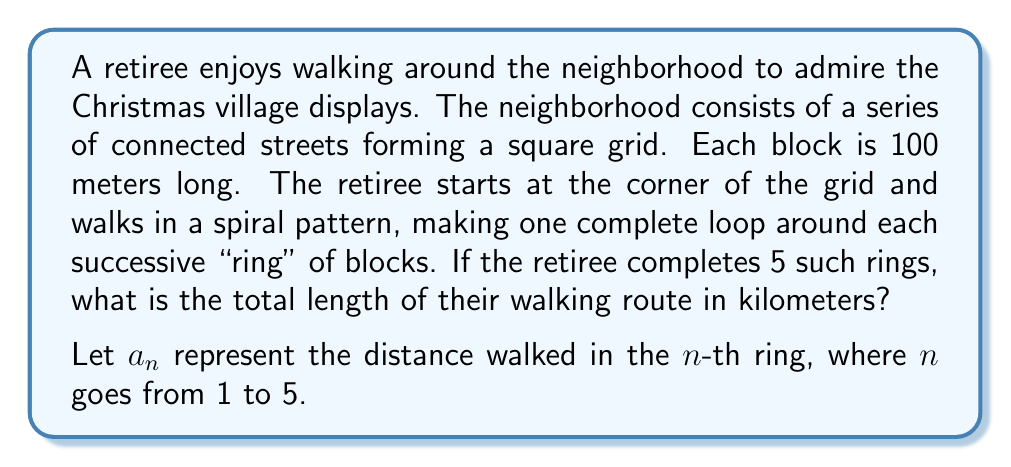Give your solution to this math problem. Let's approach this step-by-step:

1) First, we need to find the general term for the series. For each ring:
   - Ring 1: $a_1 = 4 \times 100 = 400$ meters
   - Ring 2: $a_2 = 8 \times 100 = 800$ meters
   - Ring 3: $a_3 = 12 \times 100 = 1200$ meters
   
   We can see that the general term is: $a_n = 4n \times 100 = 400n$ meters

2) Now, we need to sum this series from $n=1$ to $n=5$:

   $$S_5 = \sum_{n=1}^{5} 400n$$

3) This is an arithmetic series with $a_1 = 400$ and $d = 400$. We can use the formula for the sum of an arithmetic series:

   $$S_n = \frac{n}{2}(a_1 + a_n)$$

   where $a_n = a_1 + (n-1)d = 400 + (5-1)400 = 2000$

4) Plugging in our values:

   $$S_5 = \frac{5}{2}(400 + 2000) = \frac{5}{2}(2400) = 6000$$

5) Therefore, the total distance walked is 6000 meters or 6 kilometers.
Answer: 6 kilometers 